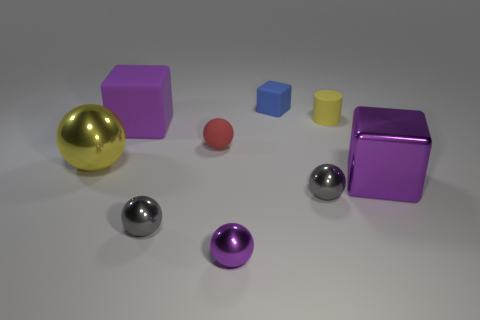Subtract all shiny blocks. How many blocks are left? 2 Add 1 purple shiny objects. How many objects exist? 10 Subtract all purple blocks. How many blocks are left? 1 Subtract 0 blue cylinders. How many objects are left? 9 Subtract all cylinders. How many objects are left? 8 Subtract 4 balls. How many balls are left? 1 Subtract all brown cubes. Subtract all green spheres. How many cubes are left? 3 Subtract all red spheres. How many purple cubes are left? 2 Subtract all tiny metal things. Subtract all yellow shiny spheres. How many objects are left? 5 Add 1 small blue things. How many small blue things are left? 2 